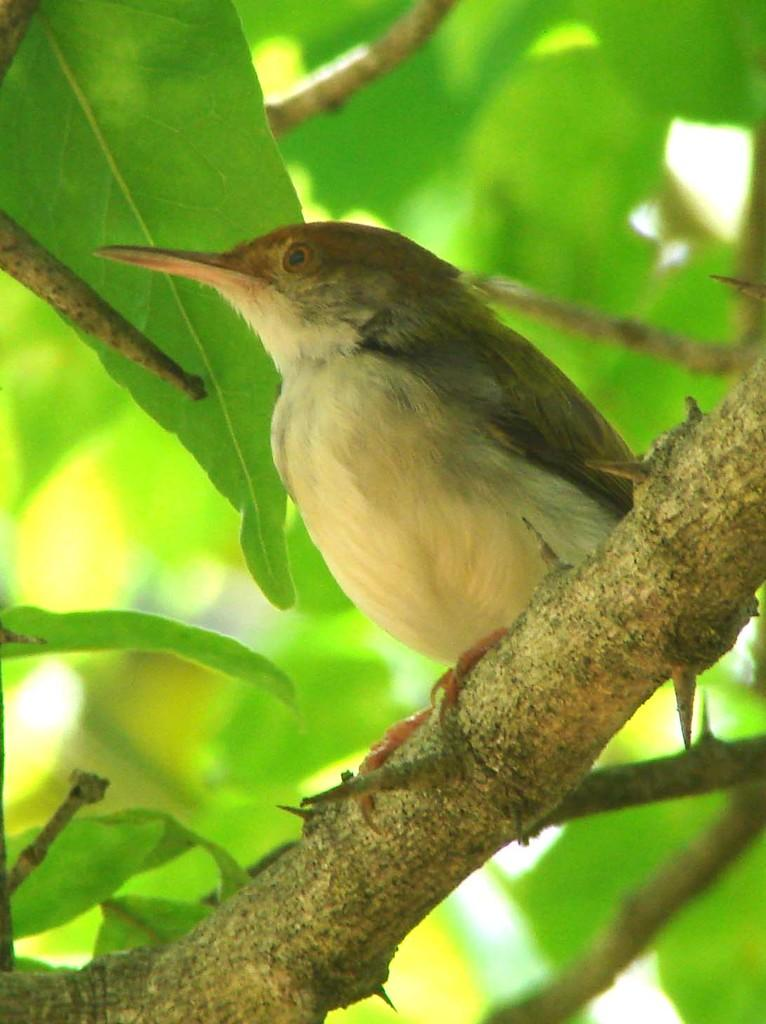What is the main subject in the center of the image? There is a bird in the center of the image. Where is the bird located? The bird is on a stem. What can be seen in the background of the image? There are leaves in the background of the image. What type of vessel is the bird using to sail across the water in the image? There is no vessel or water present in the image; it features a bird on a stem with leaves in the background. 